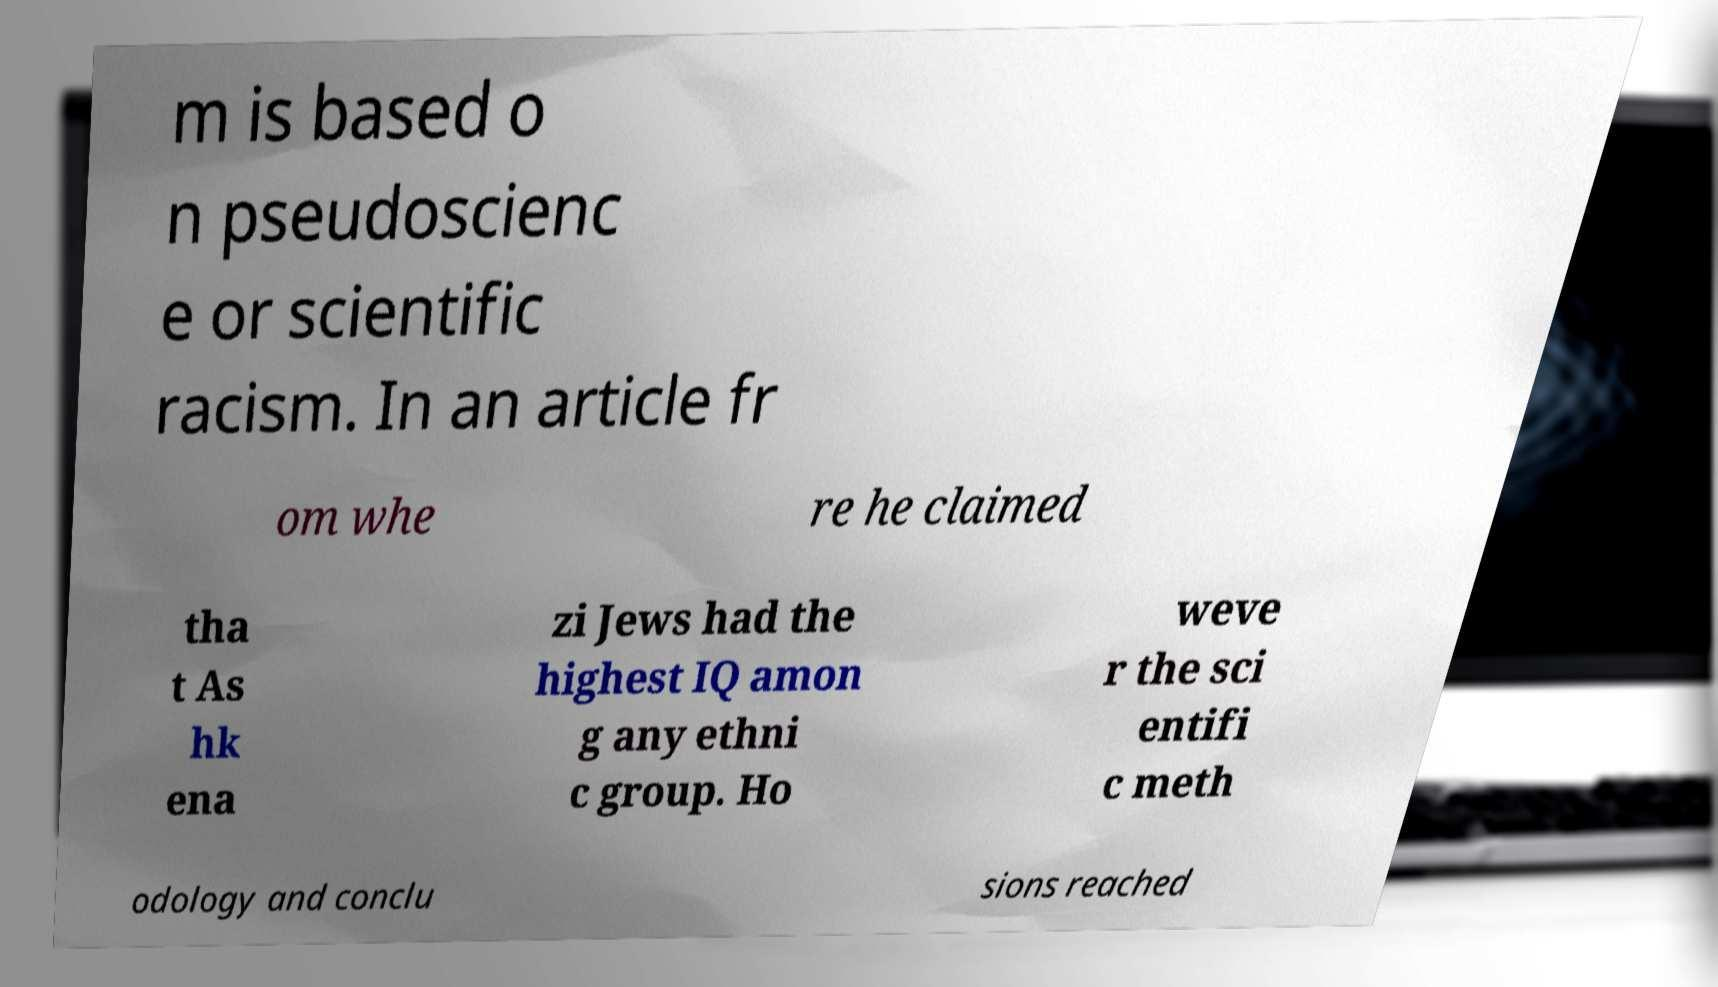For documentation purposes, I need the text within this image transcribed. Could you provide that? m is based o n pseudoscienc e or scientific racism. In an article fr om whe re he claimed tha t As hk ena zi Jews had the highest IQ amon g any ethni c group. Ho weve r the sci entifi c meth odology and conclu sions reached 